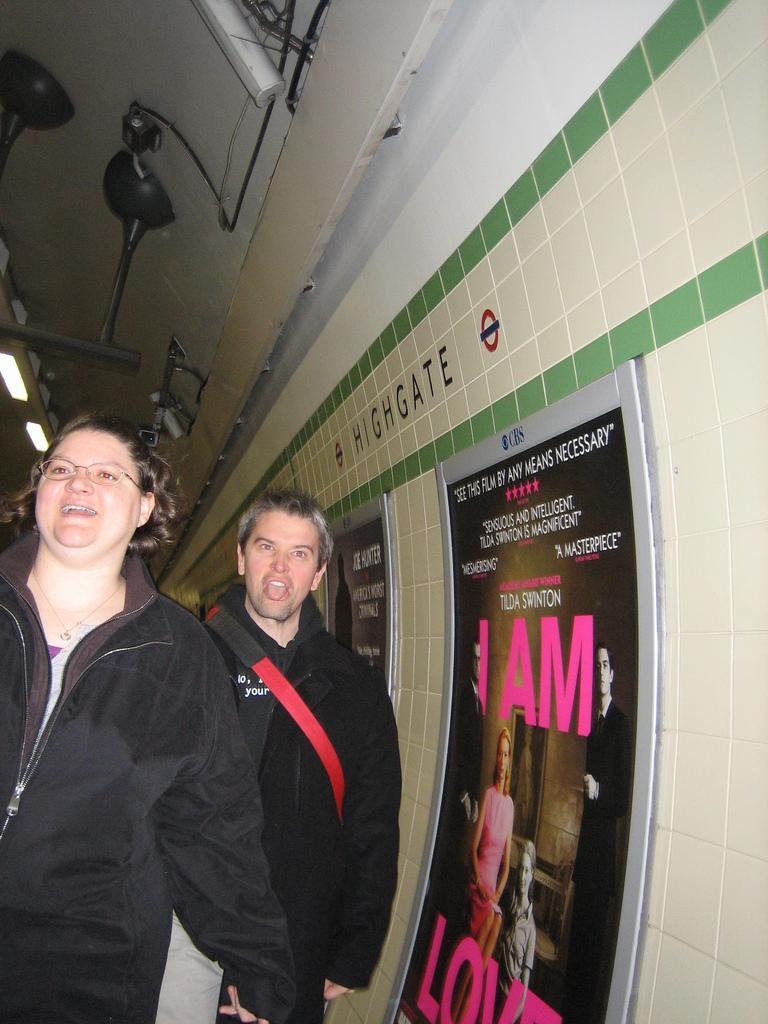Please provide a concise description of this image. In this picture I can see there are two people a man and a woman, they are smiling and wearing the spectacles and on to the right side I can see there is a wall and there are few posters pasted on it. 